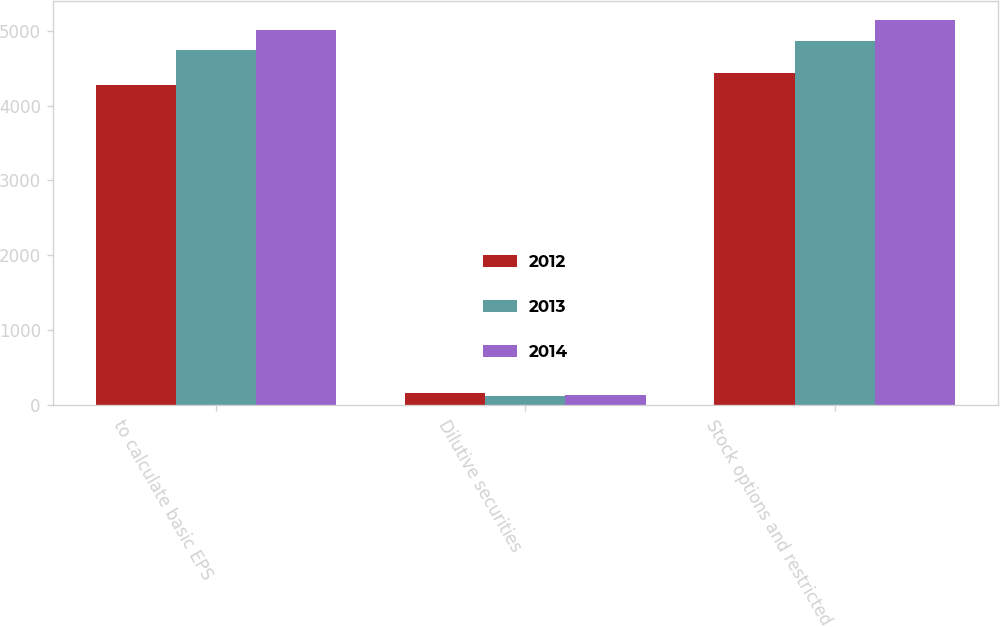Convert chart. <chart><loc_0><loc_0><loc_500><loc_500><stacked_bar_chart><ecel><fcel>to calculate basic EPS<fcel>Dilutive securities<fcel>Stock options and restricted<nl><fcel>2012<fcel>4278<fcel>157<fcel>4435<nl><fcel>2013<fcel>4737<fcel>125<fcel>4862<nl><fcel>2014<fcel>5011<fcel>131<fcel>5142<nl></chart> 